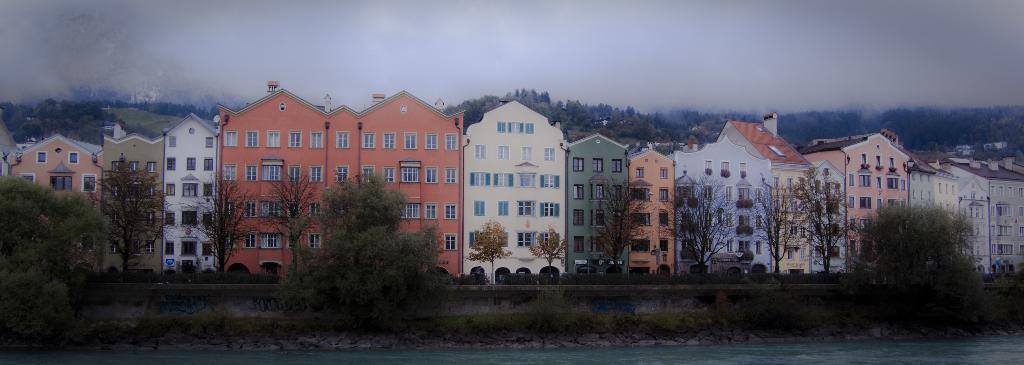Describe this image in one or two sentences. In front of the image there is water. There are rocks, plants. There is a painting on the wall. There are trees and buildings. At the top of the image there are clouds in the sky. 